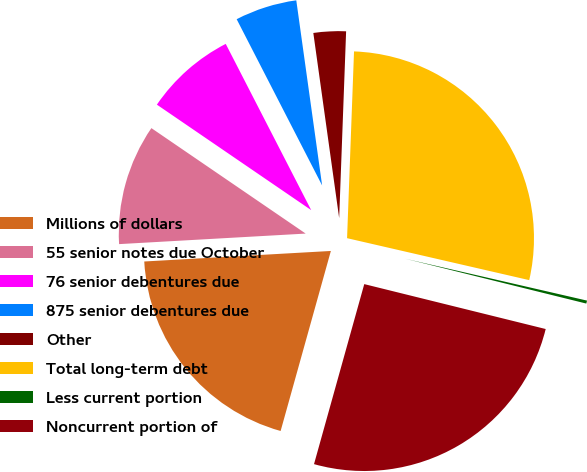<chart> <loc_0><loc_0><loc_500><loc_500><pie_chart><fcel>Millions of dollars<fcel>55 senior notes due October<fcel>76 senior debentures due<fcel>875 senior debentures due<fcel>Other<fcel>Total long-term debt<fcel>Less current portion<fcel>Noncurrent portion of<nl><fcel>19.77%<fcel>10.44%<fcel>7.9%<fcel>5.35%<fcel>2.8%<fcel>28.01%<fcel>0.26%<fcel>25.47%<nl></chart> 